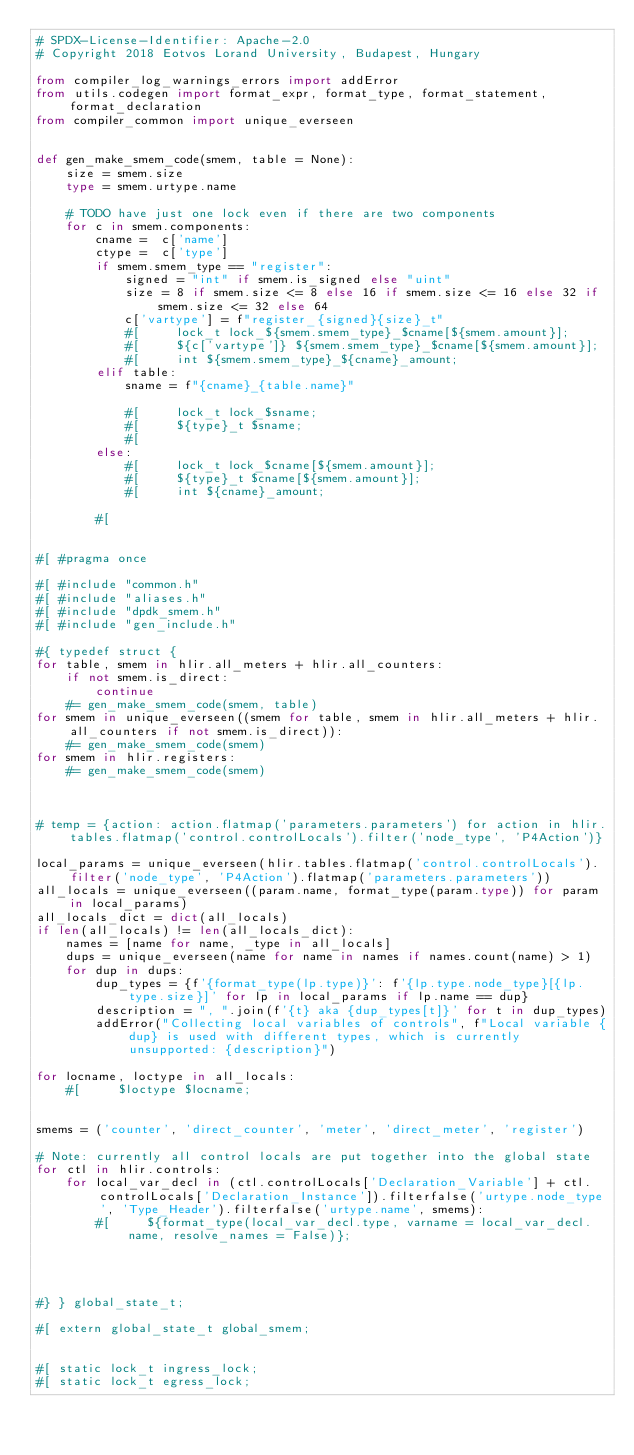<code> <loc_0><loc_0><loc_500><loc_500><_Python_># SPDX-License-Identifier: Apache-2.0
# Copyright 2018 Eotvos Lorand University, Budapest, Hungary

from compiler_log_warnings_errors import addError
from utils.codegen import format_expr, format_type, format_statement, format_declaration
from compiler_common import unique_everseen


def gen_make_smem_code(smem, table = None):
    size = smem.size
    type = smem.urtype.name

    # TODO have just one lock even if there are two components
    for c in smem.components:
        cname =  c['name']
        ctype =  c['type']
        if smem.smem_type == "register":
            signed = "int" if smem.is_signed else "uint"
            size = 8 if smem.size <= 8 else 16 if smem.size <= 16 else 32 if smem.size <= 32 else 64
            c['vartype'] = f"register_{signed}{size}_t"
            #[     lock_t lock_${smem.smem_type}_$cname[${smem.amount}];
            #[     ${c['vartype']} ${smem.smem_type}_$cname[${smem.amount}];
            #[     int ${smem.smem_type}_${cname}_amount;
        elif table:
            sname = f"{cname}_{table.name}"

            #[     lock_t lock_$sname;
            #[     ${type}_t $sname;
            #[
        else:
            #[     lock_t lock_$cname[${smem.amount}];
            #[     ${type}_t $cname[${smem.amount}];
            #[     int ${cname}_amount;

        #[


#[ #pragma once

#[ #include "common.h"
#[ #include "aliases.h"
#[ #include "dpdk_smem.h"
#[ #include "gen_include.h"

#{ typedef struct {
for table, smem in hlir.all_meters + hlir.all_counters:
    if not smem.is_direct:
        continue
    #= gen_make_smem_code(smem, table)
for smem in unique_everseen((smem for table, smem in hlir.all_meters + hlir.all_counters if not smem.is_direct)):
    #= gen_make_smem_code(smem)
for smem in hlir.registers:
    #= gen_make_smem_code(smem)



# temp = {action: action.flatmap('parameters.parameters') for action in hlir.tables.flatmap('control.controlLocals').filter('node_type', 'P4Action')}

local_params = unique_everseen(hlir.tables.flatmap('control.controlLocals').filter('node_type', 'P4Action').flatmap('parameters.parameters'))
all_locals = unique_everseen((param.name, format_type(param.type)) for param in local_params)
all_locals_dict = dict(all_locals)
if len(all_locals) != len(all_locals_dict):
    names = [name for name, _type in all_locals]
    dups = unique_everseen(name for name in names if names.count(name) > 1)
    for dup in dups:
        dup_types = {f'{format_type(lp.type)}': f'{lp.type.node_type}[{lp.type.size}]' for lp in local_params if lp.name == dup}
        description = ", ".join(f'{t} aka {dup_types[t]}' for t in dup_types)
        addError("Collecting local variables of controls", f"Local variable {dup} is used with different types, which is currently unsupported: {description}")

for locname, loctype in all_locals:
    #[     $loctype $locname;


smems = ('counter', 'direct_counter', 'meter', 'direct_meter', 'register')

# Note: currently all control locals are put together into the global state
for ctl in hlir.controls:
    for local_var_decl in (ctl.controlLocals['Declaration_Variable'] + ctl.controlLocals['Declaration_Instance']).filterfalse('urtype.node_type', 'Type_Header').filterfalse('urtype.name', smems):
        #[     ${format_type(local_var_decl.type, varname = local_var_decl.name, resolve_names = False)};




#} } global_state_t;

#[ extern global_state_t global_smem;


#[ static lock_t ingress_lock;
#[ static lock_t egress_lock;
</code> 